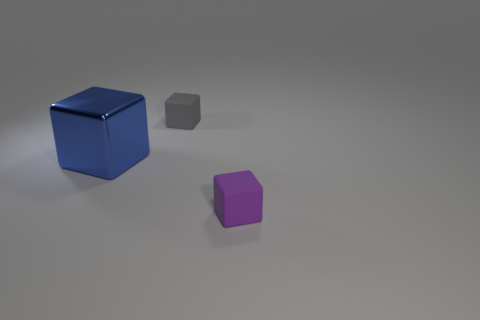Is there any other thing that has the same material as the large thing?
Make the answer very short. No. How many other things are the same shape as the big object?
Give a very brief answer. 2. There is a thing that is both on the left side of the small purple object and right of the blue metal object; what is its color?
Make the answer very short. Gray. Is there any other thing that has the same size as the metallic object?
Offer a terse response. No. How many blocks are either large blue metal things or rubber objects?
Your answer should be very brief. 3. There is a tiny rubber object on the left side of the small object to the right of the tiny matte thing left of the purple object; what color is it?
Your answer should be compact. Gray. Is the gray cube made of the same material as the big cube?
Your answer should be compact. No. What number of gray things are big shiny things or tiny cubes?
Provide a short and direct response. 1. There is a blue object; what number of matte blocks are right of it?
Your response must be concise. 2. Is the number of small yellow matte things greater than the number of tiny gray rubber cubes?
Make the answer very short. No. 